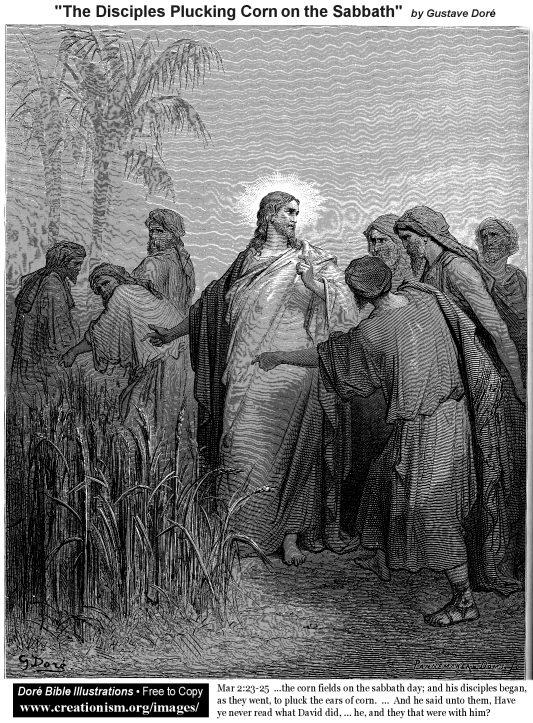How does this scene reflect the teachings of Jesus? This scene from the New Testament illustrates Jesus's teachings about the spirit of the law versus the letter of the law. By allowing His disciples to pluck and eat corn on the Sabbath, Jesus emphasizes the importance of compassion and human need over strict Sabbath observance. His response to the Pharisees underscores the belief that God's laws are intended to serve and benefit humanity, not to hinder basic needs like hunger. Imagine a modern-day equivalent of this scene. What might it look like? In a modern-day equivalent, the scene could be set in an urban community garden on a Sunday morning. A group of volunteers, led by a compassionate leader, is picking vegetables to serve at a local soup kitchen. Observers might question why they aren't resting as the tradition of a day of rest suggests, to which the leader could respond by explaining the importance of feeding the hungry and serving the community with kindness and understanding, reflecting the sharegpt4v/same timeless principles taught by Jesus in the original scene. 